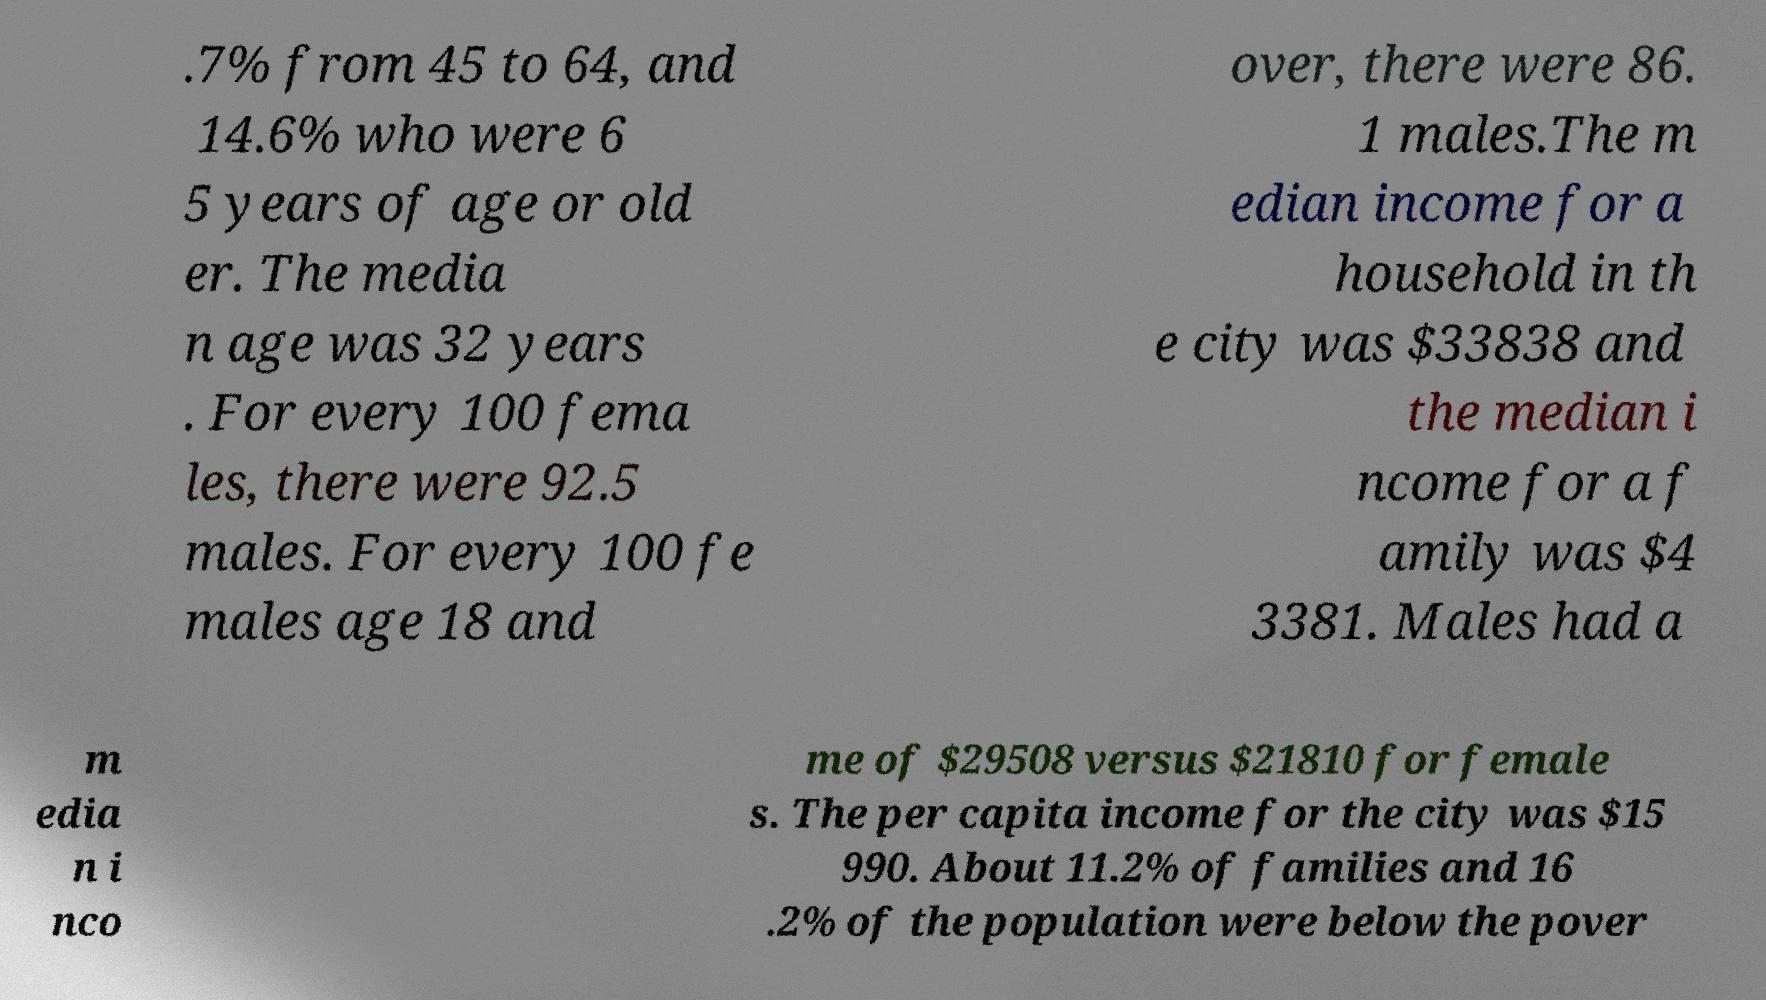There's text embedded in this image that I need extracted. Can you transcribe it verbatim? .7% from 45 to 64, and 14.6% who were 6 5 years of age or old er. The media n age was 32 years . For every 100 fema les, there were 92.5 males. For every 100 fe males age 18 and over, there were 86. 1 males.The m edian income for a household in th e city was $33838 and the median i ncome for a f amily was $4 3381. Males had a m edia n i nco me of $29508 versus $21810 for female s. The per capita income for the city was $15 990. About 11.2% of families and 16 .2% of the population were below the pover 